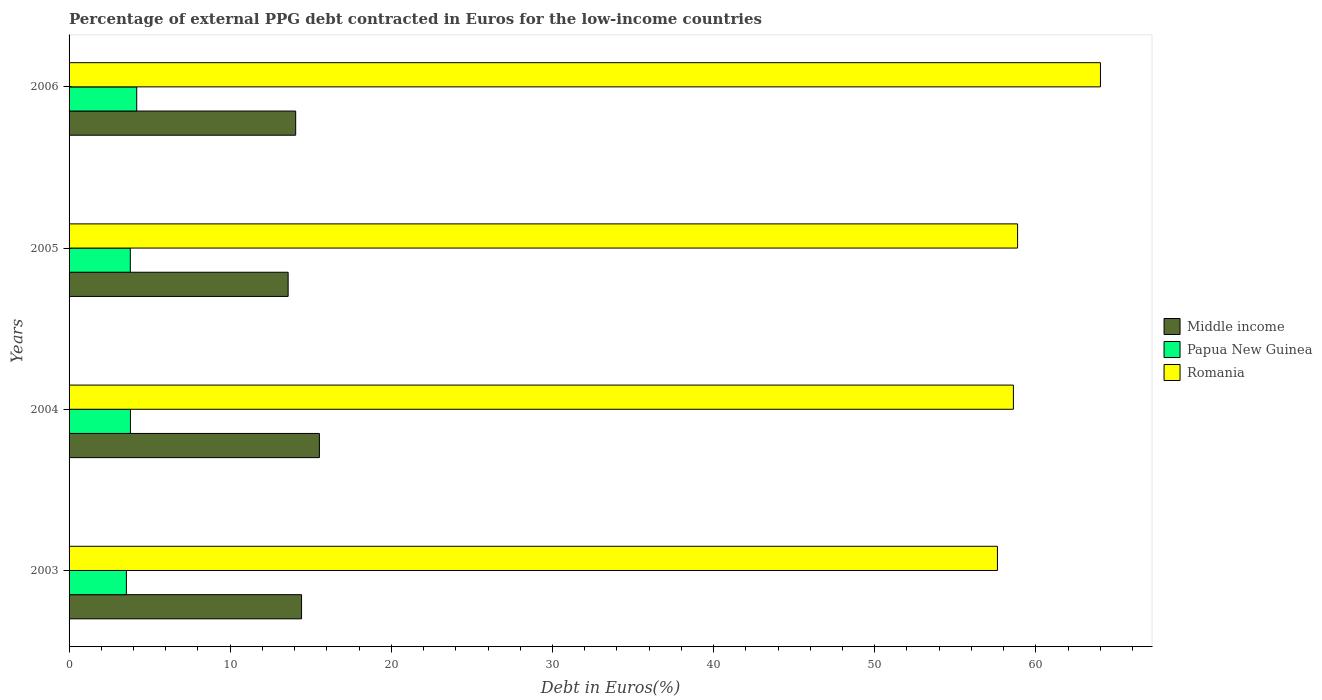How many different coloured bars are there?
Your answer should be very brief. 3. Are the number of bars per tick equal to the number of legend labels?
Your answer should be compact. Yes. Are the number of bars on each tick of the Y-axis equal?
Your answer should be very brief. Yes. How many bars are there on the 1st tick from the top?
Your response must be concise. 3. How many bars are there on the 1st tick from the bottom?
Make the answer very short. 3. What is the label of the 1st group of bars from the top?
Give a very brief answer. 2006. What is the percentage of external PPG debt contracted in Euros in Romania in 2004?
Your answer should be compact. 58.6. Across all years, what is the maximum percentage of external PPG debt contracted in Euros in Middle income?
Your response must be concise. 15.54. Across all years, what is the minimum percentage of external PPG debt contracted in Euros in Romania?
Keep it short and to the point. 57.61. In which year was the percentage of external PPG debt contracted in Euros in Middle income maximum?
Provide a succinct answer. 2004. In which year was the percentage of external PPG debt contracted in Euros in Romania minimum?
Offer a terse response. 2003. What is the total percentage of external PPG debt contracted in Euros in Romania in the graph?
Your response must be concise. 239.09. What is the difference between the percentage of external PPG debt contracted in Euros in Middle income in 2003 and that in 2005?
Your response must be concise. 0.83. What is the difference between the percentage of external PPG debt contracted in Euros in Romania in 2006 and the percentage of external PPG debt contracted in Euros in Middle income in 2003?
Provide a succinct answer. 49.58. What is the average percentage of external PPG debt contracted in Euros in Romania per year?
Give a very brief answer. 59.77. In the year 2004, what is the difference between the percentage of external PPG debt contracted in Euros in Middle income and percentage of external PPG debt contracted in Euros in Papua New Guinea?
Ensure brevity in your answer.  11.73. What is the ratio of the percentage of external PPG debt contracted in Euros in Middle income in 2004 to that in 2006?
Ensure brevity in your answer.  1.1. Is the percentage of external PPG debt contracted in Euros in Romania in 2003 less than that in 2005?
Your answer should be compact. Yes. Is the difference between the percentage of external PPG debt contracted in Euros in Middle income in 2004 and 2006 greater than the difference between the percentage of external PPG debt contracted in Euros in Papua New Guinea in 2004 and 2006?
Your response must be concise. Yes. What is the difference between the highest and the second highest percentage of external PPG debt contracted in Euros in Romania?
Provide a short and direct response. 5.14. What is the difference between the highest and the lowest percentage of external PPG debt contracted in Euros in Middle income?
Your answer should be very brief. 1.94. In how many years, is the percentage of external PPG debt contracted in Euros in Papua New Guinea greater than the average percentage of external PPG debt contracted in Euros in Papua New Guinea taken over all years?
Your answer should be compact. 1. Is the sum of the percentage of external PPG debt contracted in Euros in Middle income in 2003 and 2004 greater than the maximum percentage of external PPG debt contracted in Euros in Romania across all years?
Offer a terse response. No. What does the 3rd bar from the top in 2006 represents?
Ensure brevity in your answer.  Middle income. What does the 2nd bar from the bottom in 2003 represents?
Make the answer very short. Papua New Guinea. How many bars are there?
Your answer should be compact. 12. Are all the bars in the graph horizontal?
Offer a terse response. Yes. What is the difference between two consecutive major ticks on the X-axis?
Provide a short and direct response. 10. Are the values on the major ticks of X-axis written in scientific E-notation?
Give a very brief answer. No. What is the title of the graph?
Ensure brevity in your answer.  Percentage of external PPG debt contracted in Euros for the low-income countries. Does "Costa Rica" appear as one of the legend labels in the graph?
Your answer should be very brief. No. What is the label or title of the X-axis?
Keep it short and to the point. Debt in Euros(%). What is the label or title of the Y-axis?
Make the answer very short. Years. What is the Debt in Euros(%) of Middle income in 2003?
Your answer should be compact. 14.43. What is the Debt in Euros(%) in Papua New Guinea in 2003?
Provide a succinct answer. 3.56. What is the Debt in Euros(%) of Romania in 2003?
Your response must be concise. 57.61. What is the Debt in Euros(%) in Middle income in 2004?
Offer a very short reply. 15.54. What is the Debt in Euros(%) in Papua New Guinea in 2004?
Your answer should be compact. 3.81. What is the Debt in Euros(%) of Romania in 2004?
Keep it short and to the point. 58.6. What is the Debt in Euros(%) in Middle income in 2005?
Your answer should be compact. 13.6. What is the Debt in Euros(%) of Papua New Guinea in 2005?
Your response must be concise. 3.8. What is the Debt in Euros(%) of Romania in 2005?
Make the answer very short. 58.86. What is the Debt in Euros(%) of Middle income in 2006?
Ensure brevity in your answer.  14.06. What is the Debt in Euros(%) of Papua New Guinea in 2006?
Keep it short and to the point. 4.2. What is the Debt in Euros(%) of Romania in 2006?
Offer a very short reply. 64.01. Across all years, what is the maximum Debt in Euros(%) of Middle income?
Your answer should be very brief. 15.54. Across all years, what is the maximum Debt in Euros(%) in Papua New Guinea?
Your response must be concise. 4.2. Across all years, what is the maximum Debt in Euros(%) of Romania?
Give a very brief answer. 64.01. Across all years, what is the minimum Debt in Euros(%) of Middle income?
Give a very brief answer. 13.6. Across all years, what is the minimum Debt in Euros(%) in Papua New Guinea?
Give a very brief answer. 3.56. Across all years, what is the minimum Debt in Euros(%) in Romania?
Your answer should be compact. 57.61. What is the total Debt in Euros(%) of Middle income in the graph?
Provide a succinct answer. 57.62. What is the total Debt in Euros(%) of Papua New Guinea in the graph?
Provide a succinct answer. 15.36. What is the total Debt in Euros(%) in Romania in the graph?
Ensure brevity in your answer.  239.09. What is the difference between the Debt in Euros(%) in Middle income in 2003 and that in 2004?
Offer a very short reply. -1.11. What is the difference between the Debt in Euros(%) of Papua New Guinea in 2003 and that in 2004?
Make the answer very short. -0.25. What is the difference between the Debt in Euros(%) in Romania in 2003 and that in 2004?
Offer a very short reply. -0.99. What is the difference between the Debt in Euros(%) in Middle income in 2003 and that in 2005?
Give a very brief answer. 0.83. What is the difference between the Debt in Euros(%) of Papua New Guinea in 2003 and that in 2005?
Your answer should be compact. -0.24. What is the difference between the Debt in Euros(%) of Romania in 2003 and that in 2005?
Provide a succinct answer. -1.25. What is the difference between the Debt in Euros(%) of Middle income in 2003 and that in 2006?
Keep it short and to the point. 0.36. What is the difference between the Debt in Euros(%) of Papua New Guinea in 2003 and that in 2006?
Make the answer very short. -0.64. What is the difference between the Debt in Euros(%) of Romania in 2003 and that in 2006?
Your response must be concise. -6.39. What is the difference between the Debt in Euros(%) in Middle income in 2004 and that in 2005?
Offer a very short reply. 1.94. What is the difference between the Debt in Euros(%) in Papua New Guinea in 2004 and that in 2005?
Make the answer very short. 0.01. What is the difference between the Debt in Euros(%) in Romania in 2004 and that in 2005?
Ensure brevity in your answer.  -0.26. What is the difference between the Debt in Euros(%) of Middle income in 2004 and that in 2006?
Offer a terse response. 1.47. What is the difference between the Debt in Euros(%) of Papua New Guinea in 2004 and that in 2006?
Ensure brevity in your answer.  -0.39. What is the difference between the Debt in Euros(%) in Romania in 2004 and that in 2006?
Make the answer very short. -5.4. What is the difference between the Debt in Euros(%) in Middle income in 2005 and that in 2006?
Provide a short and direct response. -0.47. What is the difference between the Debt in Euros(%) of Papua New Guinea in 2005 and that in 2006?
Your response must be concise. -0.4. What is the difference between the Debt in Euros(%) of Romania in 2005 and that in 2006?
Give a very brief answer. -5.14. What is the difference between the Debt in Euros(%) in Middle income in 2003 and the Debt in Euros(%) in Papua New Guinea in 2004?
Provide a short and direct response. 10.62. What is the difference between the Debt in Euros(%) in Middle income in 2003 and the Debt in Euros(%) in Romania in 2004?
Keep it short and to the point. -44.18. What is the difference between the Debt in Euros(%) in Papua New Guinea in 2003 and the Debt in Euros(%) in Romania in 2004?
Offer a very short reply. -55.05. What is the difference between the Debt in Euros(%) in Middle income in 2003 and the Debt in Euros(%) in Papua New Guinea in 2005?
Provide a succinct answer. 10.63. What is the difference between the Debt in Euros(%) of Middle income in 2003 and the Debt in Euros(%) of Romania in 2005?
Your response must be concise. -44.44. What is the difference between the Debt in Euros(%) of Papua New Guinea in 2003 and the Debt in Euros(%) of Romania in 2005?
Offer a terse response. -55.31. What is the difference between the Debt in Euros(%) of Middle income in 2003 and the Debt in Euros(%) of Papua New Guinea in 2006?
Offer a very short reply. 10.23. What is the difference between the Debt in Euros(%) of Middle income in 2003 and the Debt in Euros(%) of Romania in 2006?
Give a very brief answer. -49.58. What is the difference between the Debt in Euros(%) in Papua New Guinea in 2003 and the Debt in Euros(%) in Romania in 2006?
Give a very brief answer. -60.45. What is the difference between the Debt in Euros(%) in Middle income in 2004 and the Debt in Euros(%) in Papua New Guinea in 2005?
Offer a very short reply. 11.74. What is the difference between the Debt in Euros(%) of Middle income in 2004 and the Debt in Euros(%) of Romania in 2005?
Make the answer very short. -43.33. What is the difference between the Debt in Euros(%) in Papua New Guinea in 2004 and the Debt in Euros(%) in Romania in 2005?
Your answer should be very brief. -55.06. What is the difference between the Debt in Euros(%) in Middle income in 2004 and the Debt in Euros(%) in Papua New Guinea in 2006?
Your answer should be compact. 11.34. What is the difference between the Debt in Euros(%) of Middle income in 2004 and the Debt in Euros(%) of Romania in 2006?
Ensure brevity in your answer.  -48.47. What is the difference between the Debt in Euros(%) of Papua New Guinea in 2004 and the Debt in Euros(%) of Romania in 2006?
Make the answer very short. -60.2. What is the difference between the Debt in Euros(%) in Middle income in 2005 and the Debt in Euros(%) in Papua New Guinea in 2006?
Make the answer very short. 9.4. What is the difference between the Debt in Euros(%) of Middle income in 2005 and the Debt in Euros(%) of Romania in 2006?
Your answer should be very brief. -50.41. What is the difference between the Debt in Euros(%) of Papua New Guinea in 2005 and the Debt in Euros(%) of Romania in 2006?
Your response must be concise. -60.21. What is the average Debt in Euros(%) of Middle income per year?
Provide a succinct answer. 14.41. What is the average Debt in Euros(%) of Papua New Guinea per year?
Provide a succinct answer. 3.84. What is the average Debt in Euros(%) in Romania per year?
Your response must be concise. 59.77. In the year 2003, what is the difference between the Debt in Euros(%) of Middle income and Debt in Euros(%) of Papua New Guinea?
Ensure brevity in your answer.  10.87. In the year 2003, what is the difference between the Debt in Euros(%) of Middle income and Debt in Euros(%) of Romania?
Your response must be concise. -43.19. In the year 2003, what is the difference between the Debt in Euros(%) of Papua New Guinea and Debt in Euros(%) of Romania?
Your response must be concise. -54.06. In the year 2004, what is the difference between the Debt in Euros(%) in Middle income and Debt in Euros(%) in Papua New Guinea?
Make the answer very short. 11.73. In the year 2004, what is the difference between the Debt in Euros(%) of Middle income and Debt in Euros(%) of Romania?
Offer a terse response. -43.07. In the year 2004, what is the difference between the Debt in Euros(%) of Papua New Guinea and Debt in Euros(%) of Romania?
Keep it short and to the point. -54.8. In the year 2005, what is the difference between the Debt in Euros(%) of Middle income and Debt in Euros(%) of Papua New Guinea?
Ensure brevity in your answer.  9.79. In the year 2005, what is the difference between the Debt in Euros(%) of Middle income and Debt in Euros(%) of Romania?
Your answer should be very brief. -45.27. In the year 2005, what is the difference between the Debt in Euros(%) of Papua New Guinea and Debt in Euros(%) of Romania?
Provide a short and direct response. -55.06. In the year 2006, what is the difference between the Debt in Euros(%) in Middle income and Debt in Euros(%) in Papua New Guinea?
Offer a very short reply. 9.87. In the year 2006, what is the difference between the Debt in Euros(%) of Middle income and Debt in Euros(%) of Romania?
Keep it short and to the point. -49.94. In the year 2006, what is the difference between the Debt in Euros(%) of Papua New Guinea and Debt in Euros(%) of Romania?
Ensure brevity in your answer.  -59.81. What is the ratio of the Debt in Euros(%) of Middle income in 2003 to that in 2004?
Your answer should be compact. 0.93. What is the ratio of the Debt in Euros(%) of Papua New Guinea in 2003 to that in 2004?
Your answer should be compact. 0.93. What is the ratio of the Debt in Euros(%) of Romania in 2003 to that in 2004?
Your answer should be compact. 0.98. What is the ratio of the Debt in Euros(%) in Middle income in 2003 to that in 2005?
Provide a succinct answer. 1.06. What is the ratio of the Debt in Euros(%) in Papua New Guinea in 2003 to that in 2005?
Give a very brief answer. 0.94. What is the ratio of the Debt in Euros(%) of Romania in 2003 to that in 2005?
Give a very brief answer. 0.98. What is the ratio of the Debt in Euros(%) of Papua New Guinea in 2003 to that in 2006?
Provide a succinct answer. 0.85. What is the ratio of the Debt in Euros(%) of Romania in 2003 to that in 2006?
Offer a very short reply. 0.9. What is the ratio of the Debt in Euros(%) in Middle income in 2004 to that in 2005?
Offer a very short reply. 1.14. What is the ratio of the Debt in Euros(%) of Papua New Guinea in 2004 to that in 2005?
Provide a short and direct response. 1. What is the ratio of the Debt in Euros(%) in Romania in 2004 to that in 2005?
Offer a very short reply. 1. What is the ratio of the Debt in Euros(%) of Middle income in 2004 to that in 2006?
Your response must be concise. 1.1. What is the ratio of the Debt in Euros(%) of Papua New Guinea in 2004 to that in 2006?
Give a very brief answer. 0.91. What is the ratio of the Debt in Euros(%) of Romania in 2004 to that in 2006?
Keep it short and to the point. 0.92. What is the ratio of the Debt in Euros(%) of Middle income in 2005 to that in 2006?
Your answer should be compact. 0.97. What is the ratio of the Debt in Euros(%) in Papua New Guinea in 2005 to that in 2006?
Offer a very short reply. 0.91. What is the ratio of the Debt in Euros(%) of Romania in 2005 to that in 2006?
Keep it short and to the point. 0.92. What is the difference between the highest and the second highest Debt in Euros(%) of Middle income?
Give a very brief answer. 1.11. What is the difference between the highest and the second highest Debt in Euros(%) in Papua New Guinea?
Provide a succinct answer. 0.39. What is the difference between the highest and the second highest Debt in Euros(%) of Romania?
Offer a terse response. 5.14. What is the difference between the highest and the lowest Debt in Euros(%) of Middle income?
Your answer should be compact. 1.94. What is the difference between the highest and the lowest Debt in Euros(%) of Papua New Guinea?
Offer a terse response. 0.64. What is the difference between the highest and the lowest Debt in Euros(%) of Romania?
Your response must be concise. 6.39. 